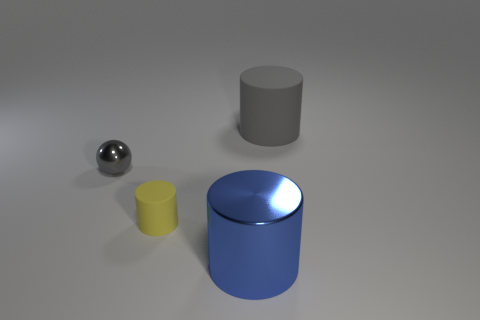Does the cylinder in front of the small yellow matte cylinder have the same material as the small sphere?
Your response must be concise. Yes. How many other matte things have the same shape as the big blue object?
Provide a succinct answer. 2. What number of big objects are spheres or gray objects?
Ensure brevity in your answer.  1. There is a large metal thing on the right side of the ball; does it have the same color as the tiny sphere?
Offer a terse response. No. Is the color of the large cylinder that is behind the shiny sphere the same as the small matte object left of the blue metallic thing?
Give a very brief answer. No. Are there any other big objects that have the same material as the large blue object?
Offer a terse response. No. What number of cyan things are tiny matte cylinders or tiny metallic things?
Your answer should be compact. 0. Are there more tiny gray metal balls in front of the small yellow cylinder than blue shiny things?
Ensure brevity in your answer.  No. Do the blue object and the gray shiny sphere have the same size?
Make the answer very short. No. There is another cylinder that is the same material as the tiny yellow cylinder; what color is it?
Give a very brief answer. Gray. 